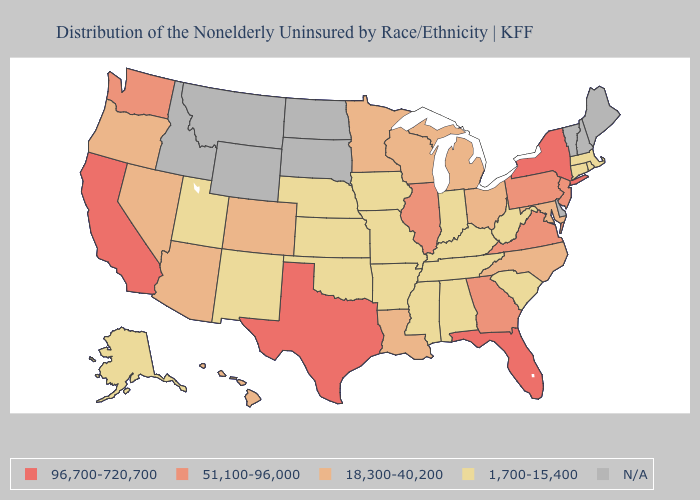Among the states that border Wyoming , which have the highest value?
Be succinct. Colorado. What is the lowest value in states that border Iowa?
Give a very brief answer. 1,700-15,400. What is the value of South Dakota?
Answer briefly. N/A. What is the lowest value in the West?
Answer briefly. 1,700-15,400. What is the value of Alaska?
Short answer required. 1,700-15,400. What is the highest value in the MidWest ?
Write a very short answer. 51,100-96,000. Name the states that have a value in the range N/A?
Short answer required. Delaware, Idaho, Maine, Montana, New Hampshire, North Dakota, South Dakota, Vermont, Wyoming. What is the value of Hawaii?
Write a very short answer. 18,300-40,200. Does Indiana have the lowest value in the MidWest?
Concise answer only. Yes. What is the highest value in the South ?
Concise answer only. 96,700-720,700. Among the states that border Pennsylvania , does New York have the highest value?
Write a very short answer. Yes. Is the legend a continuous bar?
Answer briefly. No. What is the highest value in the USA?
Write a very short answer. 96,700-720,700. Name the states that have a value in the range 18,300-40,200?
Short answer required. Arizona, Colorado, Hawaii, Louisiana, Maryland, Michigan, Minnesota, Nevada, North Carolina, Ohio, Oregon, Wisconsin. 